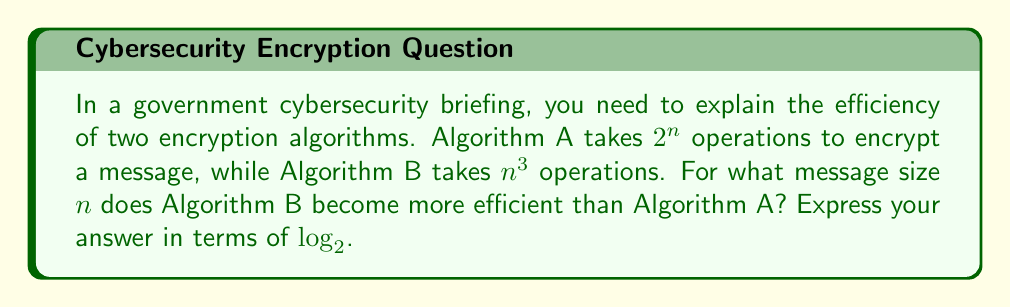Provide a solution to this math problem. Let's approach this step-by-step:

1) Algorithm A takes $2^n$ operations
2) Algorithm B takes $n^3$ operations

3) We want to find when $n^3 < 2^n$

4) Taking $\log_2$ of both sides:
   $\log_2(n^3) < \log_2(2^n)$

5) Using the logarithm property $\log_a(x^m) = m\log_a(x)$:
   $3\log_2(n) < n$

6) This inequality is satisfied when:
   $\frac{3\log_2(n)}{n} < 1$

7) Let $f(n) = \frac{3\log_2(n)}{n}$

8) We can find the maximum of $f(n)$ by differentiating and setting to zero:
   $f'(n) = \frac{3}{n\ln(2)} - \frac{3\log_2(n)}{n^2} = 0$

9) Solving this:
   $\frac{3}{n\ln(2)} = \frac{3\log_2(n)}{n^2}$
   $n = e \cdot \log_2(n)$

10) The solution to this is approximately $n \approx 9.97$

11) Therefore, for $n \geq 10$, Algorithm B becomes more efficient.

12) We can express this answer in terms of $\log_2$ as:
    $n > \log_2(1024)$ (since $2^{10} = 1024$)
Answer: $n > \log_2(1024)$ 